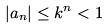<formula> <loc_0><loc_0><loc_500><loc_500>| a _ { n } | \leq k ^ { n } < 1</formula> 